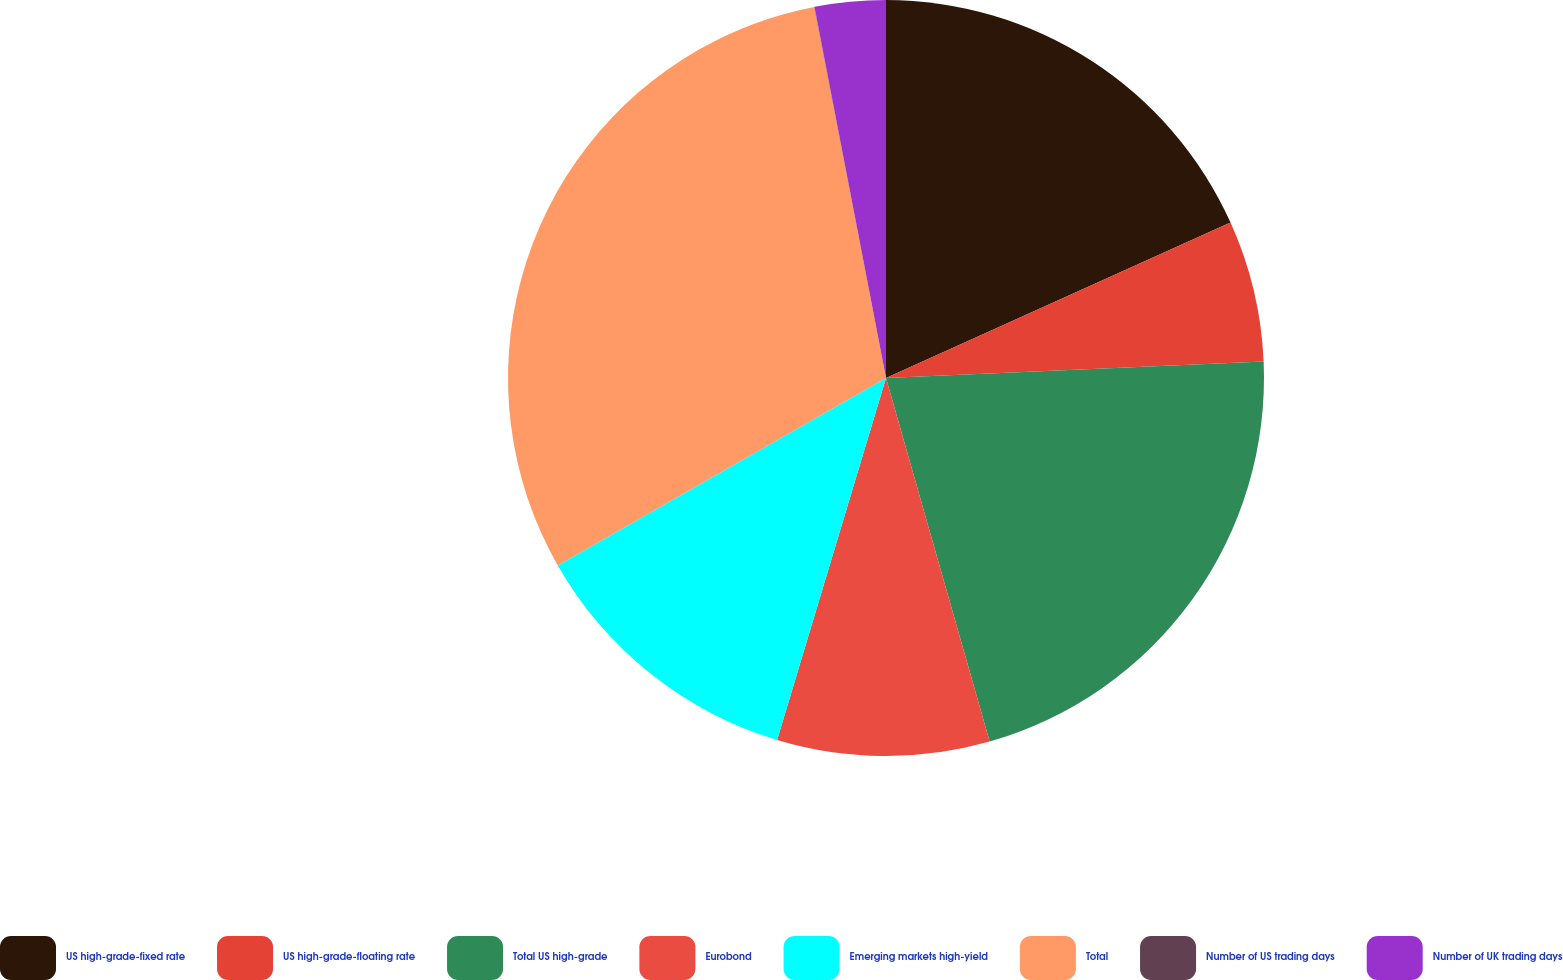Convert chart. <chart><loc_0><loc_0><loc_500><loc_500><pie_chart><fcel>US high-grade-fixed rate<fcel>US high-grade-floating rate<fcel>Total US high-grade<fcel>Eurobond<fcel>Emerging markets high-yield<fcel>Total<fcel>Number of US trading days<fcel>Number of UK trading days<nl><fcel>18.25%<fcel>6.05%<fcel>21.27%<fcel>9.07%<fcel>12.09%<fcel>30.21%<fcel>0.01%<fcel>3.03%<nl></chart> 